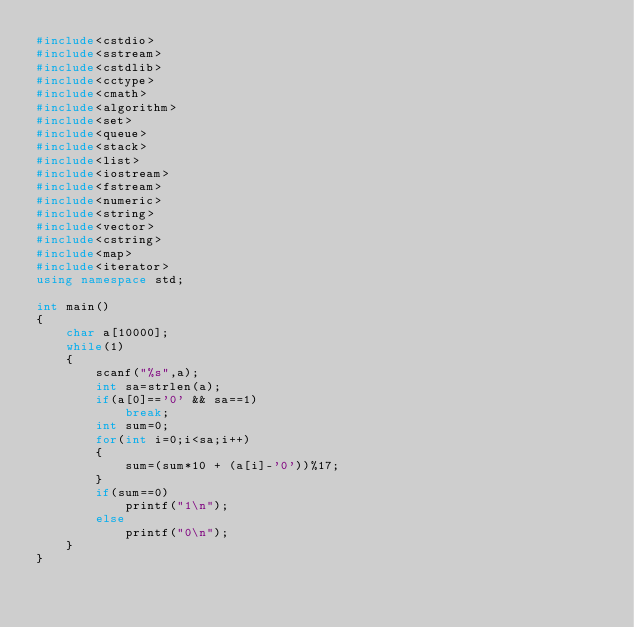Convert code to text. <code><loc_0><loc_0><loc_500><loc_500><_C++_>#include<cstdio>
#include<sstream>
#include<cstdlib>
#include<cctype>
#include<cmath>
#include<algorithm>
#include<set>
#include<queue>
#include<stack>
#include<list>
#include<iostream>
#include<fstream>
#include<numeric>
#include<string>
#include<vector>
#include<cstring>
#include<map>
#include<iterator>
using namespace std;

int main()
{
    char a[10000];
    while(1)
    {
        scanf("%s",a);
        int sa=strlen(a);
        if(a[0]=='0' && sa==1)
            break;
        int sum=0;
        for(int i=0;i<sa;i++)
        {
            sum=(sum*10 + (a[i]-'0'))%17;
        }
        if(sum==0)
            printf("1\n");
        else
            printf("0\n");
    }
}
</code> 